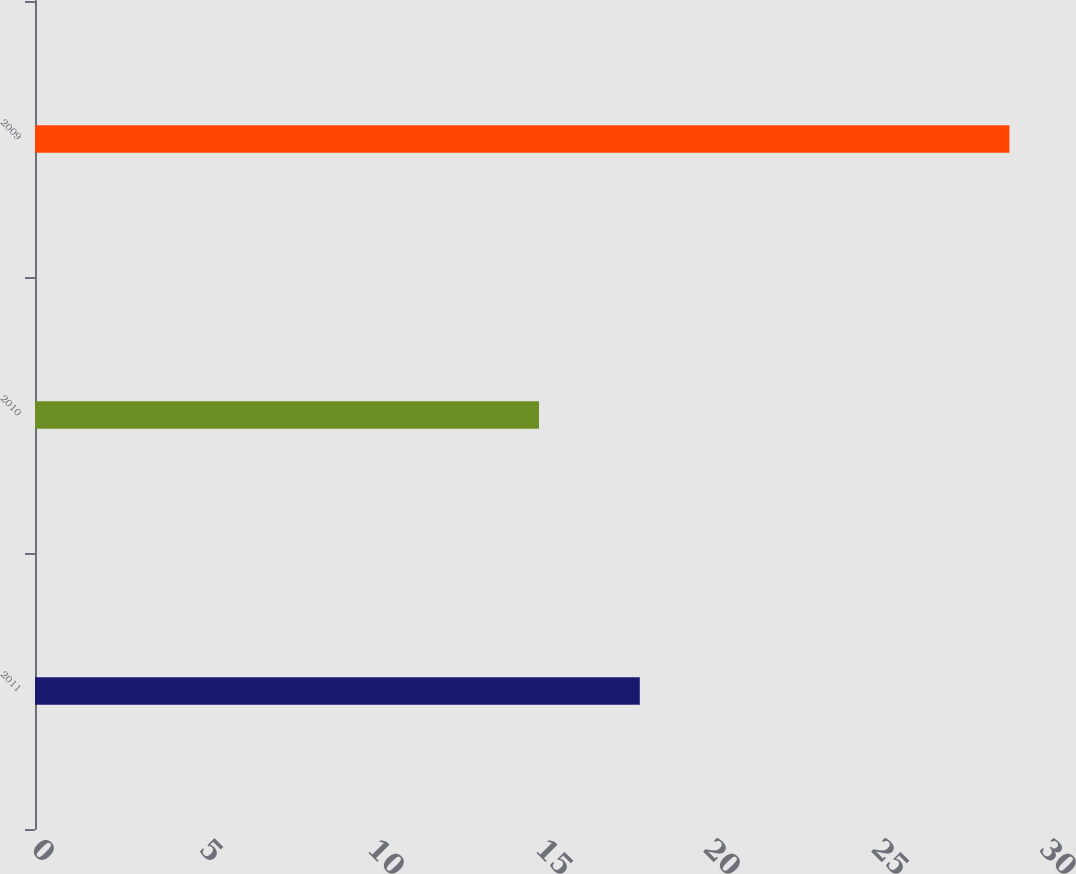<chart> <loc_0><loc_0><loc_500><loc_500><bar_chart><fcel>2011<fcel>2010<fcel>2009<nl><fcel>18<fcel>15<fcel>29<nl></chart> 